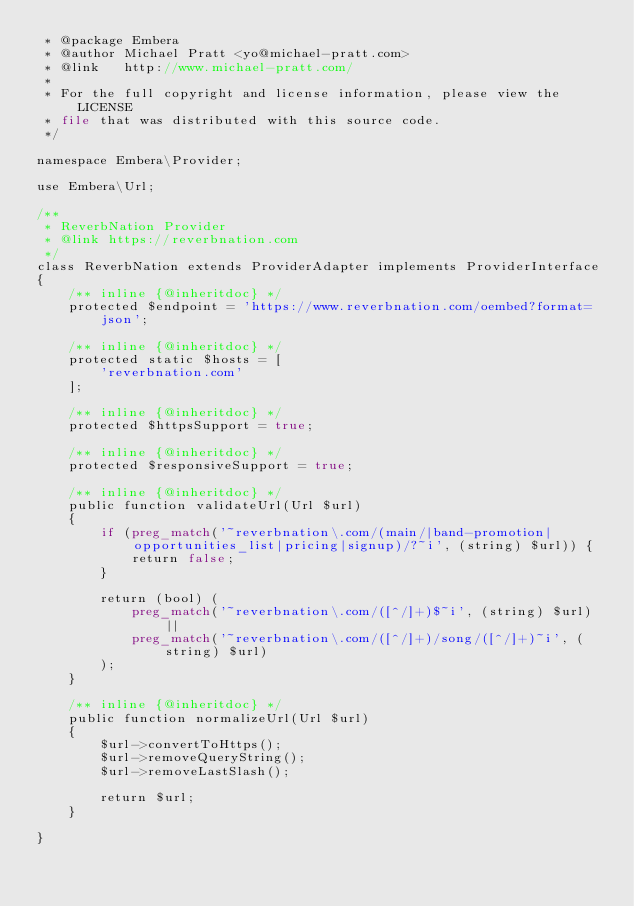<code> <loc_0><loc_0><loc_500><loc_500><_PHP_> * @package Embera
 * @author Michael Pratt <yo@michael-pratt.com>
 * @link   http://www.michael-pratt.com/
 *
 * For the full copyright and license information, please view the LICENSE
 * file that was distributed with this source code.
 */

namespace Embera\Provider;

use Embera\Url;

/**
 * ReverbNation Provider
 * @link https://reverbnation.com
 */
class ReverbNation extends ProviderAdapter implements ProviderInterface
{
    /** inline {@inheritdoc} */
    protected $endpoint = 'https://www.reverbnation.com/oembed?format=json';

    /** inline {@inheritdoc} */
    protected static $hosts = [
        'reverbnation.com'
    ];

    /** inline {@inheritdoc} */
    protected $httpsSupport = true;

    /** inline {@inheritdoc} */
    protected $responsiveSupport = true;

    /** inline {@inheritdoc} */
    public function validateUrl(Url $url)
    {
        if (preg_match('~reverbnation\.com/(main/|band-promotion|opportunities_list|pricing|signup)/?~i', (string) $url)) {
            return false;
        }

        return (bool) (
            preg_match('~reverbnation\.com/([^/]+)$~i', (string) $url) ||
            preg_match('~reverbnation\.com/([^/]+)/song/([^/]+)~i', (string) $url)
        );
    }

    /** inline {@inheritdoc} */
    public function normalizeUrl(Url $url)
    {
        $url->convertToHttps();
        $url->removeQueryString();
        $url->removeLastSlash();

        return $url;
    }

}
</code> 